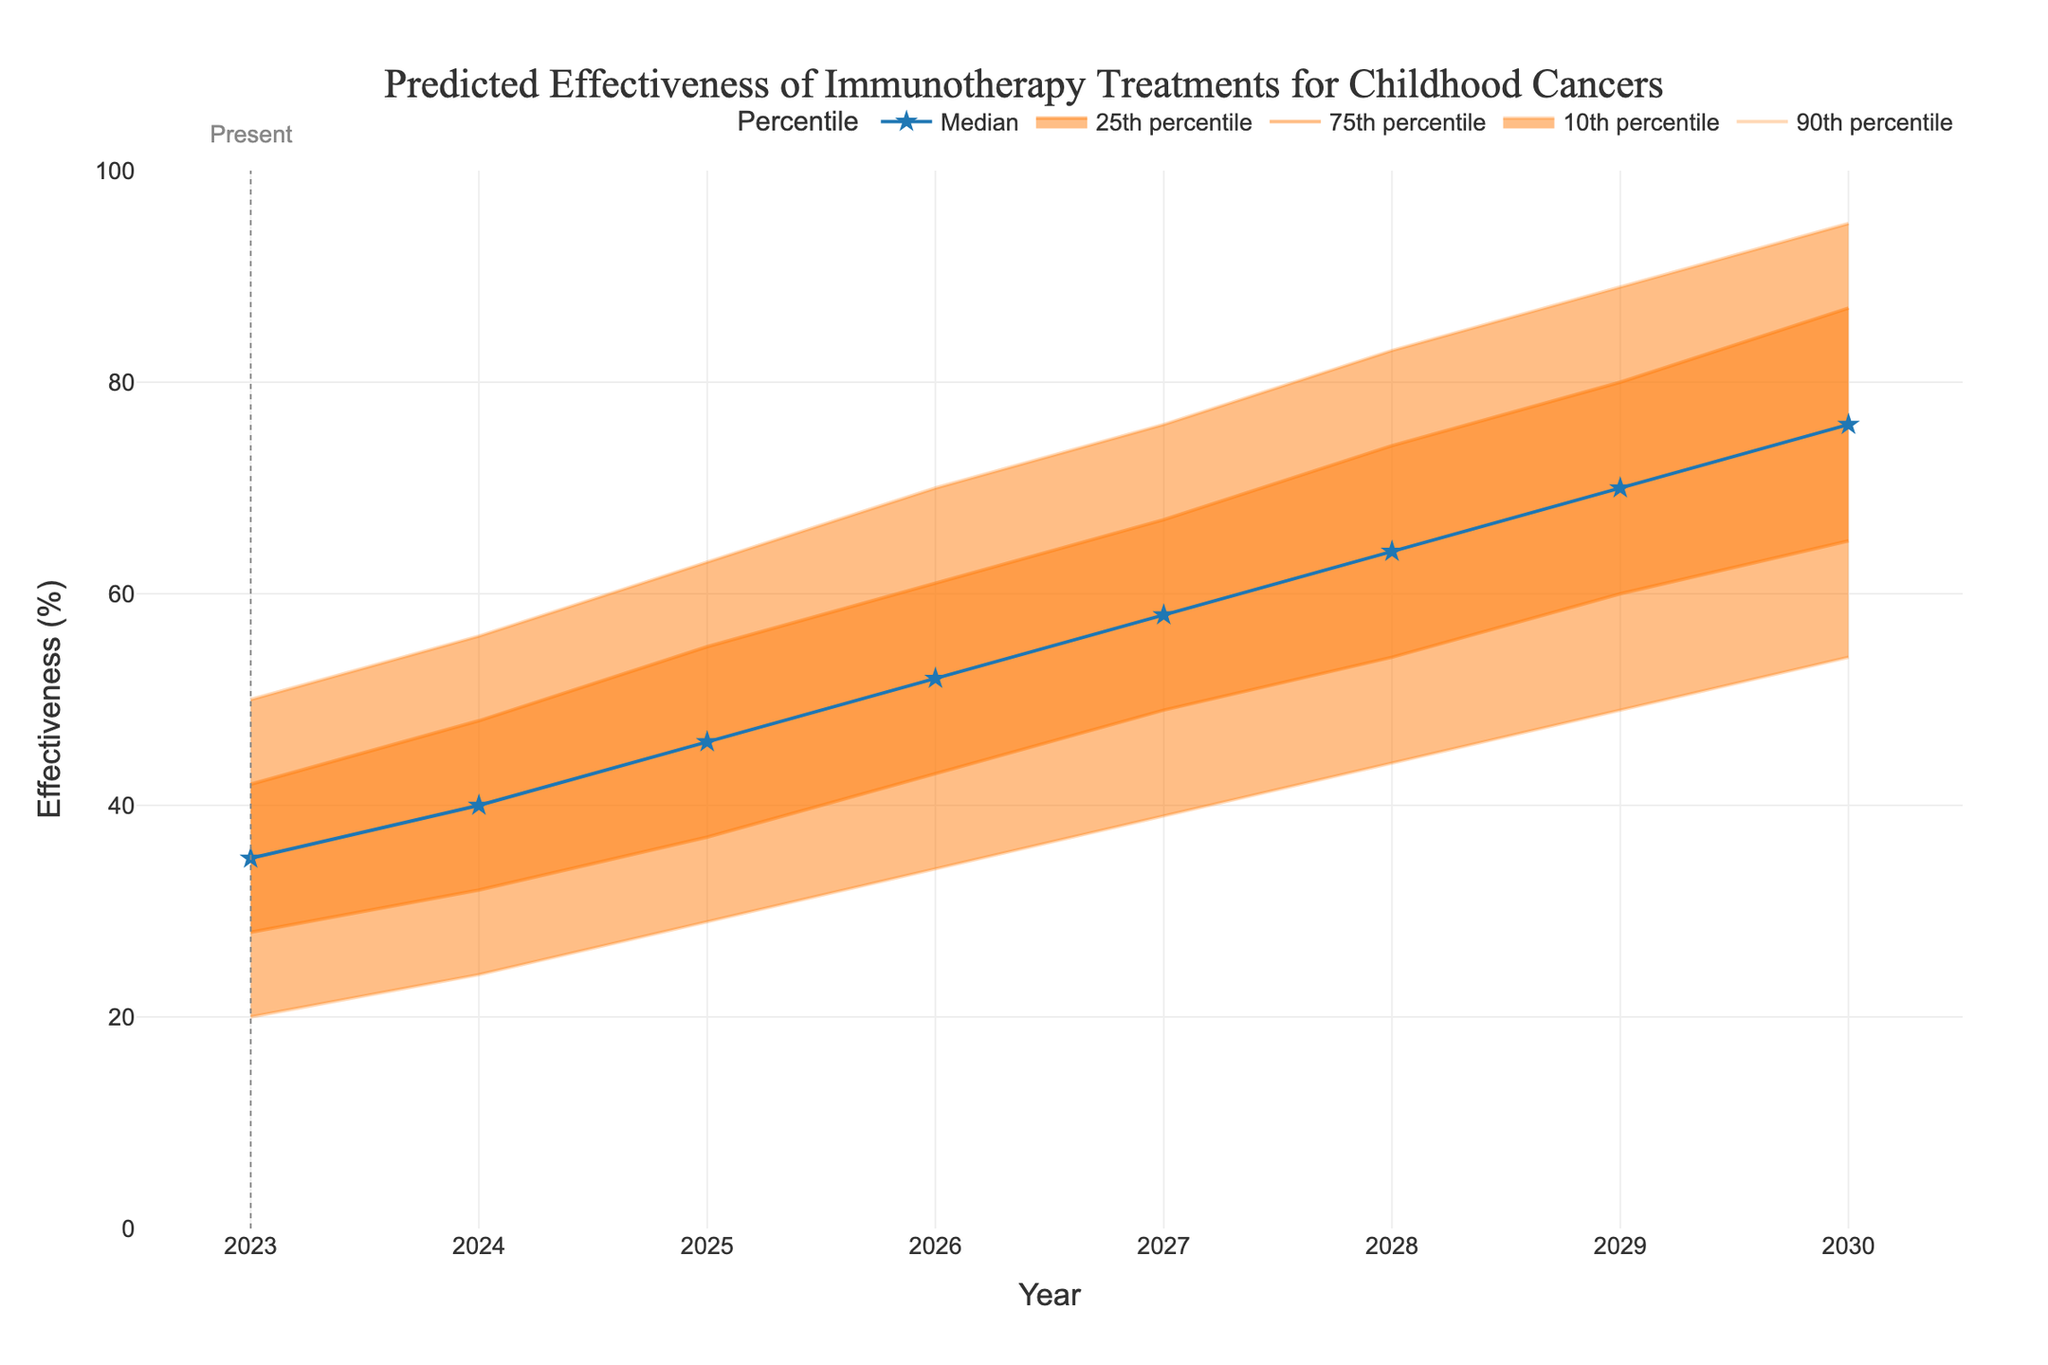What is the title of the chart? The title of the chart is displayed at the top of the figure. By looking at the top, you can see the title mentioned.
Answer: Predicted Effectiveness of Immunotherapy Treatments for Childhood Cancers What is the median predicted effectiveness in the year 2026? To find this, locate the year 2026 on the x-axis then look at the median line, which is represented by the blue line with star markers, to see the corresponding effectiveness value.
Answer: 52% Which year shows the highest median predicted effectiveness? Find the blue line with star markers representing the median values and identify the highest point along this line. The x-axis value corresponding to this peak gives the year.
Answer: 2030 How does the predicted effectiveness distribution change from 2023 to 2027? Compare the fan chart bands from 2023 to 2027. Notice how the bands widen, indicating an increasing range of predicted effectiveness values and a rise in the medians.
Answer: The distribution widens, and the median increases What is the range of predicted effectiveness for the year 2028 from the 10th to the 90th percentile? Locate the year 2028 on the x-axis. Identify the effectiveness values at the 10th percentile (lower orange band) and 90th percentile (upper orange band). Subtract the 10th percentile value from the 90th percentile value.
Answer: 63% (83% - 20%) Which year has the smallest range between the 25th and 75th percentiles? Examine the width of the interquartile range, represented by the distance between the lines for the 25th and 75th percentiles on the fan chart. Determine the year with the narrowest band between these percentiles.
Answer: 2023 How does the predicted median effectiveness change from 2023 to 2030? Observe the median line marked by stars from 2023 to 2030. Note the trend and the general direction in which the line progresses over these years.
Answer: It increases from 35% to 76% What is the predicted effectiveness at the 25th percentile for the year 2029? Look at the year 2029 on the x-axis and then trace vertically to the orange line that represents the 25th percentile to read the effectiveness value.
Answer: 60% In which year does the 75th percentile first exceed 70% predicted effectiveness? Find the line for the 75th percentile and note where it crosses above the 70% mark. Trace that point vertically down to the x-axis to find the corresponding year.
Answer: 2027 By how much does the 90th percentile predicted effectiveness increase from 2024 to 2028? Compare the 90th percentile effectiveness values for the years 2024 and 2028 identified by the uppermost orange band. Subtract the 2024 value from the 2028 value.
Answer: 27% (83% - 56%) 